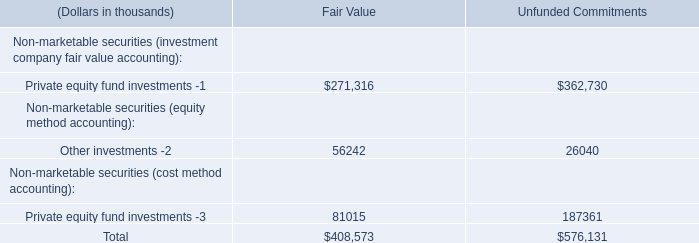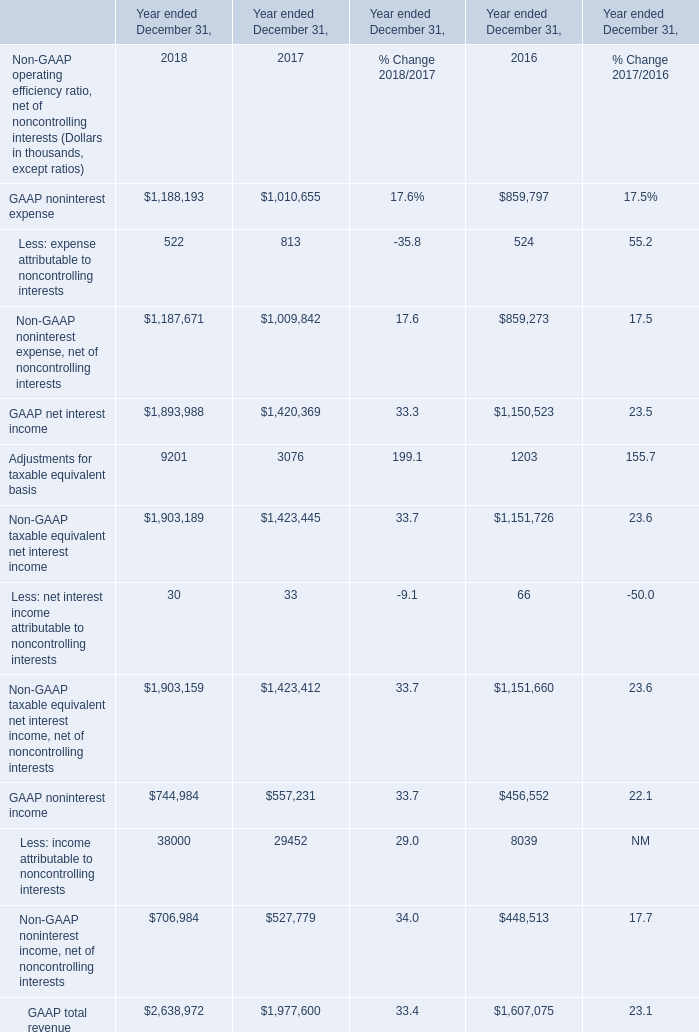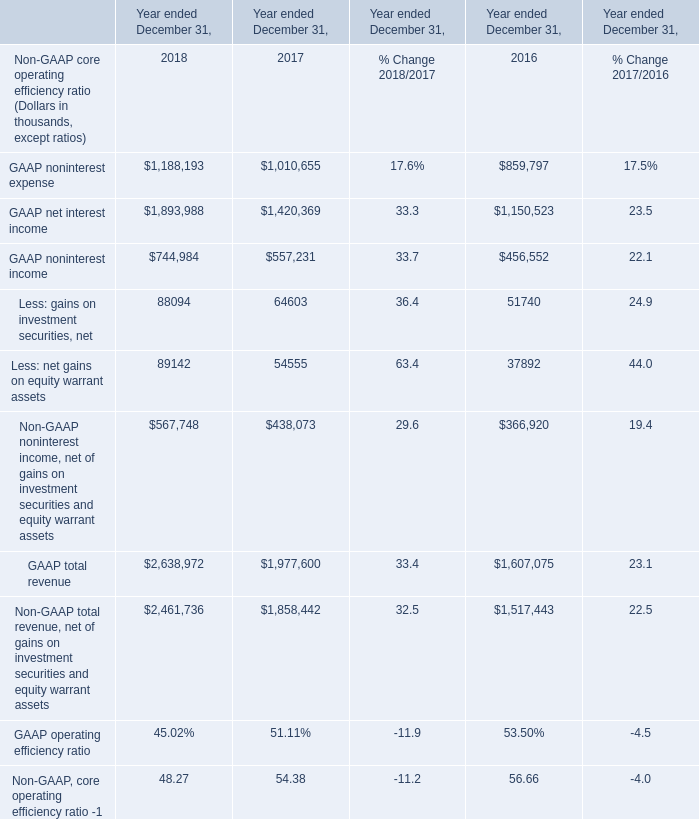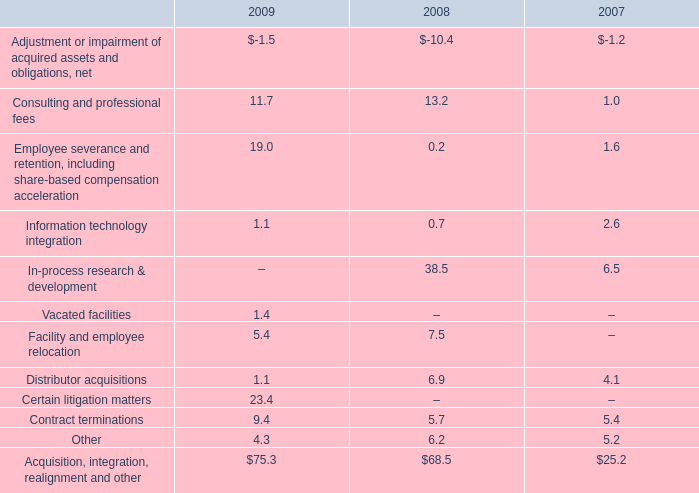what is the expense related to severance and other employee termination-related costs as a percentage of the acquisition integration realignment and other expenses in 2009? 
Computations: (19.0 / 75.3)
Answer: 0.25232. 